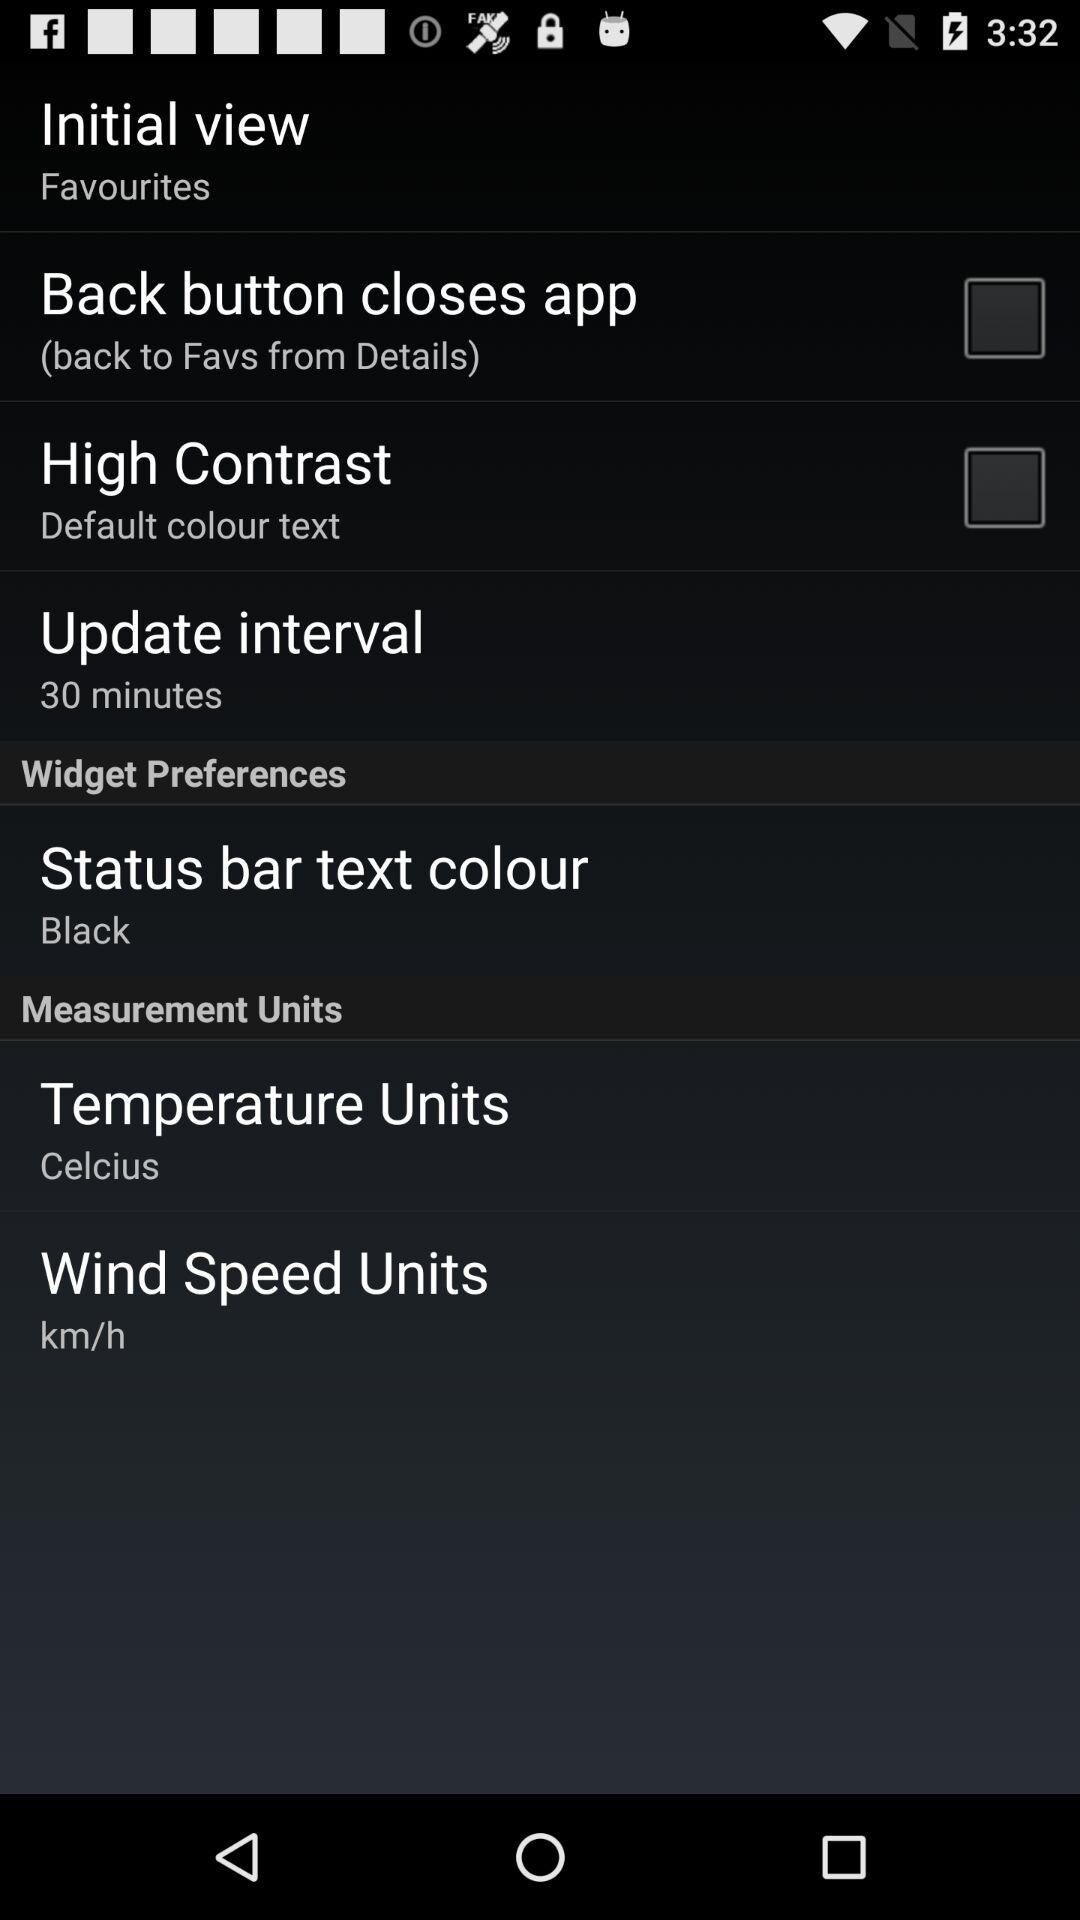What's the status of "High Contrast"? The status is "off". 